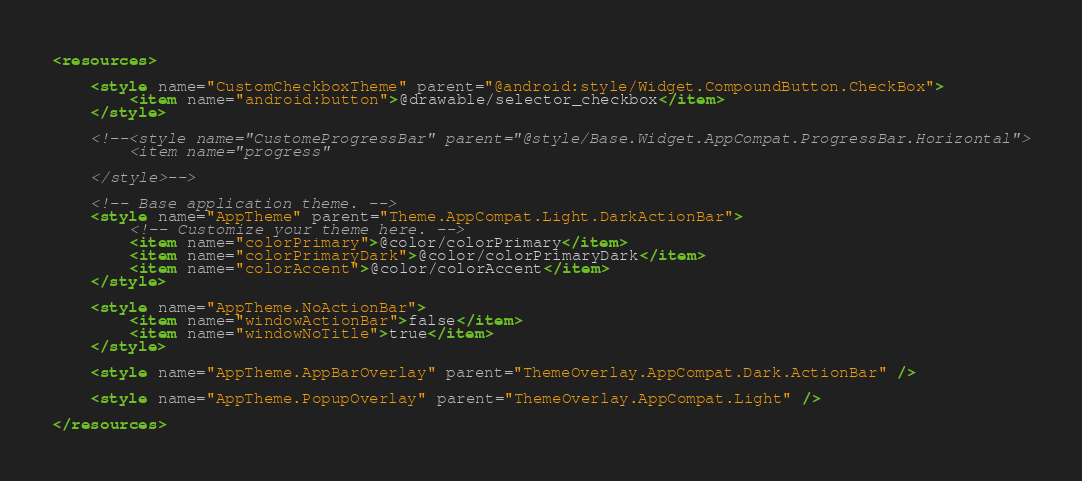Convert code to text. <code><loc_0><loc_0><loc_500><loc_500><_XML_><resources>

    <style name="CustomCheckboxTheme" parent="@android:style/Widget.CompoundButton.CheckBox">
        <item name="android:button">@drawable/selector_checkbox</item>
    </style>

    <!--<style name="CustomeProgressBar" parent="@style/Base.Widget.AppCompat.ProgressBar.Horizontal">
        <item name="progress"

    </style>-->

    <!-- Base application theme. -->
    <style name="AppTheme" parent="Theme.AppCompat.Light.DarkActionBar">
        <!-- Customize your theme here. -->
        <item name="colorPrimary">@color/colorPrimary</item>
        <item name="colorPrimaryDark">@color/colorPrimaryDark</item>
        <item name="colorAccent">@color/colorAccent</item>
    </style>

    <style name="AppTheme.NoActionBar">
        <item name="windowActionBar">false</item>
        <item name="windowNoTitle">true</item>
    </style>

    <style name="AppTheme.AppBarOverlay" parent="ThemeOverlay.AppCompat.Dark.ActionBar" />

    <style name="AppTheme.PopupOverlay" parent="ThemeOverlay.AppCompat.Light" />

</resources>
</code> 